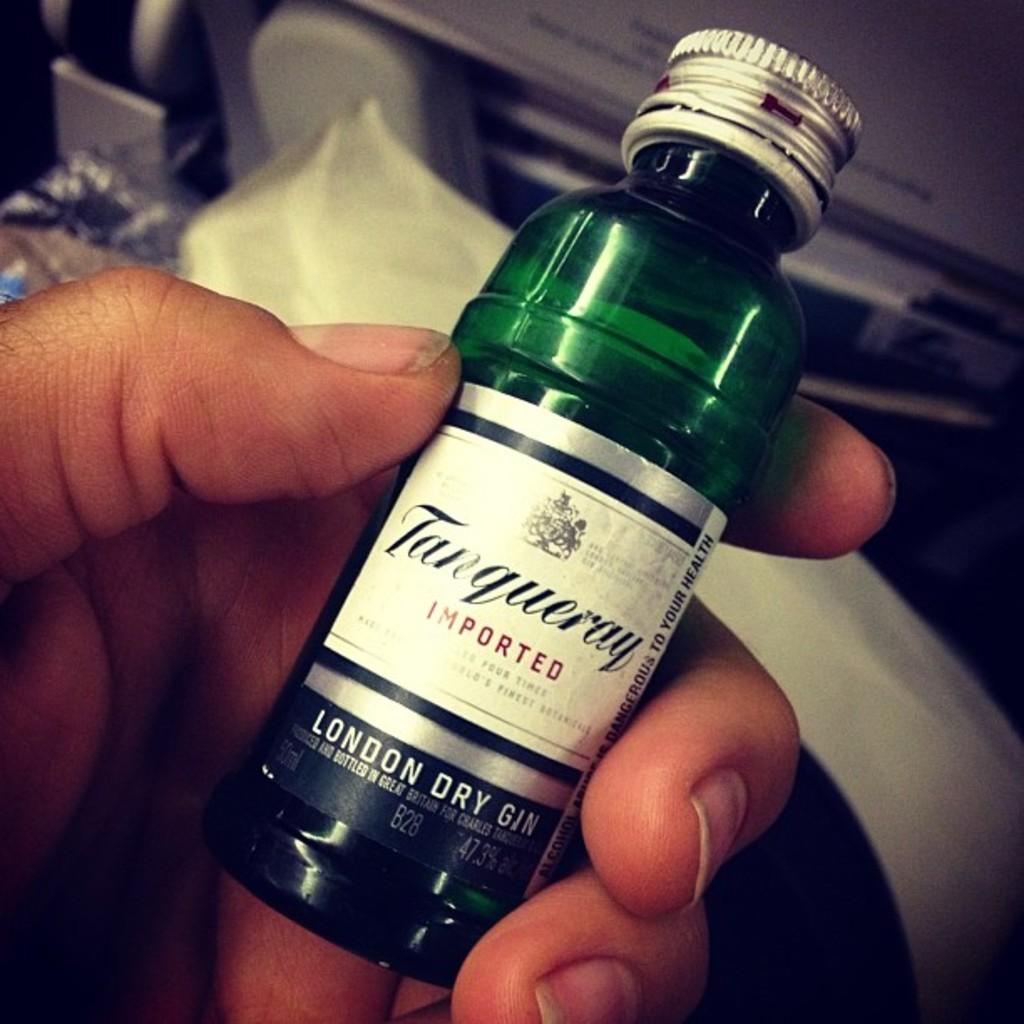What object is being held in the image? There is a bottle in the image, and it is being held in a hand. What song is being sung by the bottle in the image? There is no song being sung by the bottle in the image, as it is an inanimate object. 